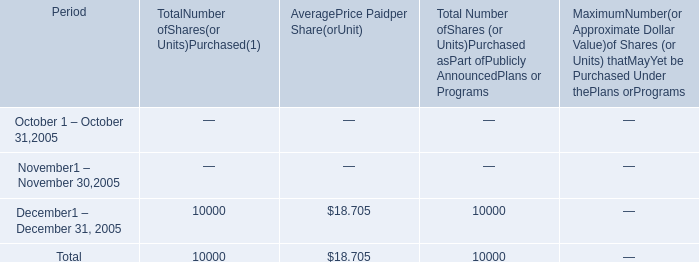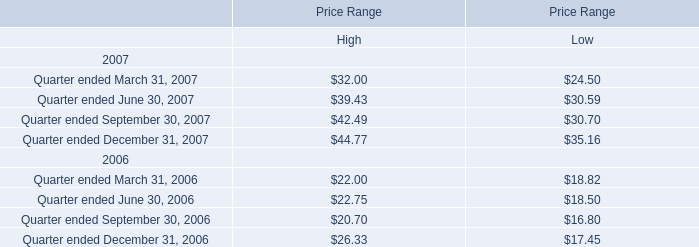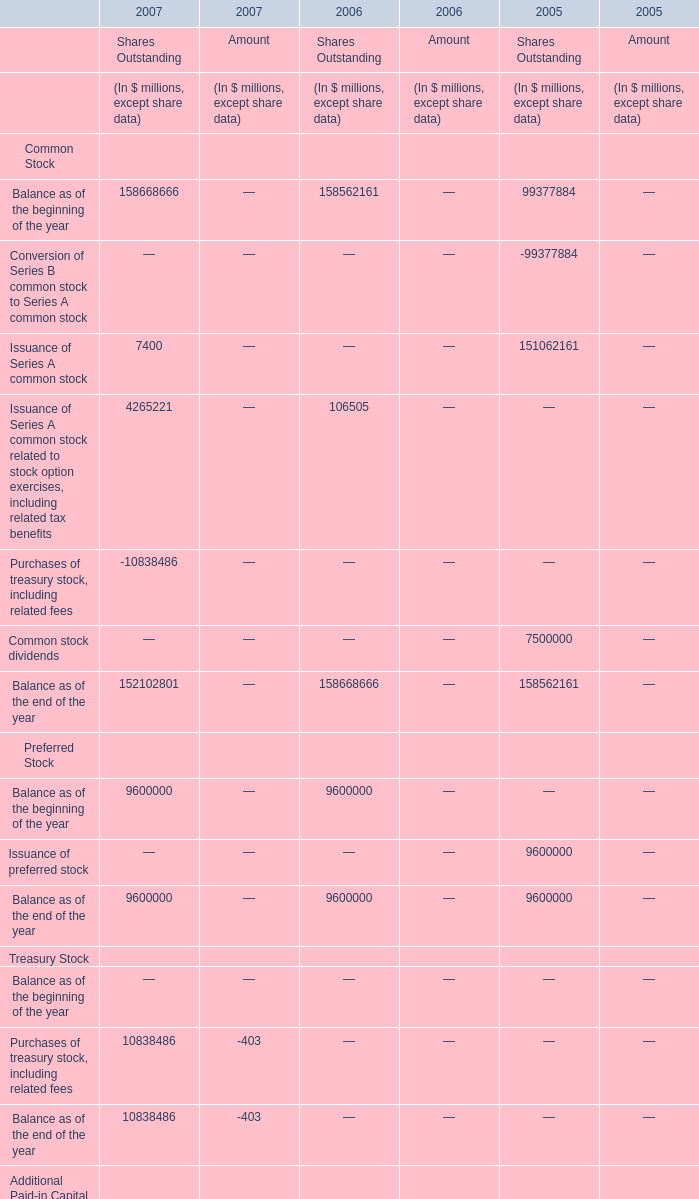If Balance as of the beginning of the year of Shares Outstanding develops with the same increasing rate in 2007, what will it reach in 2008? (in million) 
Computations: (158668666 * (1 + ((158668666 - 158562161) / 158562161)))
Answer: 158775242.5386. 